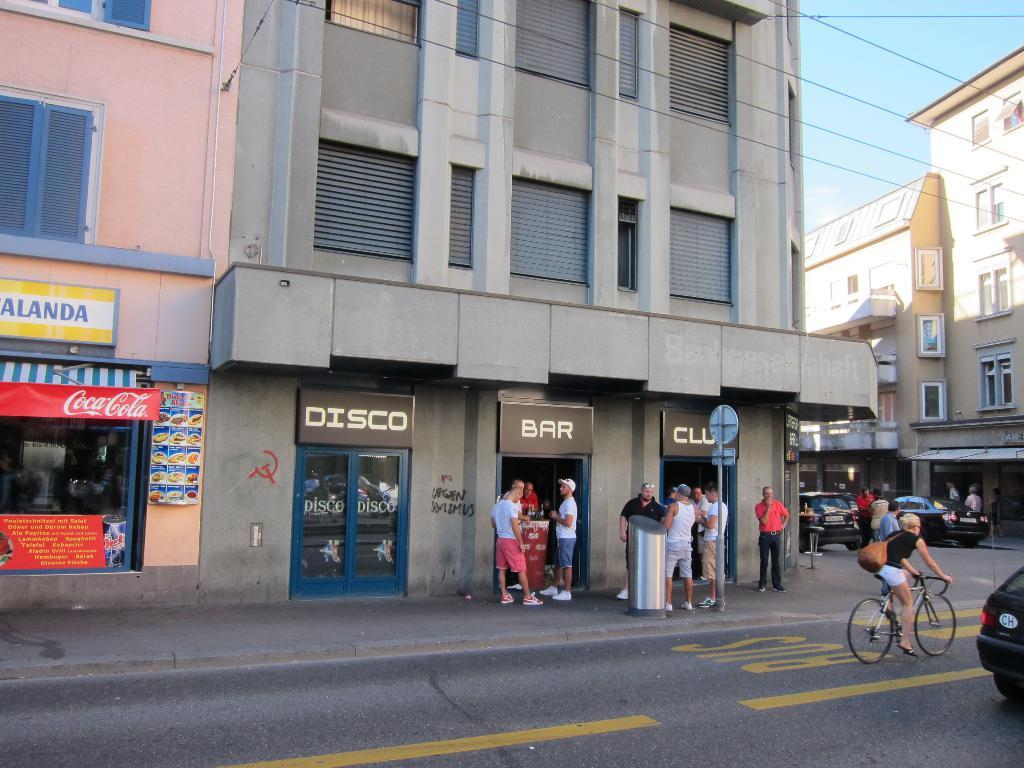What type of structures are present in the image? There are buildings in the image. What type of establishments can be found within these structures? There are stores in the image. Are there any people visible in the image? Yes, there are people standing in the image. What is located at the bottom of the image? There is a road at the bottom of the image. What is moving along the road? There are vehicles on the road. What can be seen at the top of the image? The sky is visible at the top of the image. What is the minute teaching rate in the image? There is no mention of a minute, teaching, or rate in the image. 